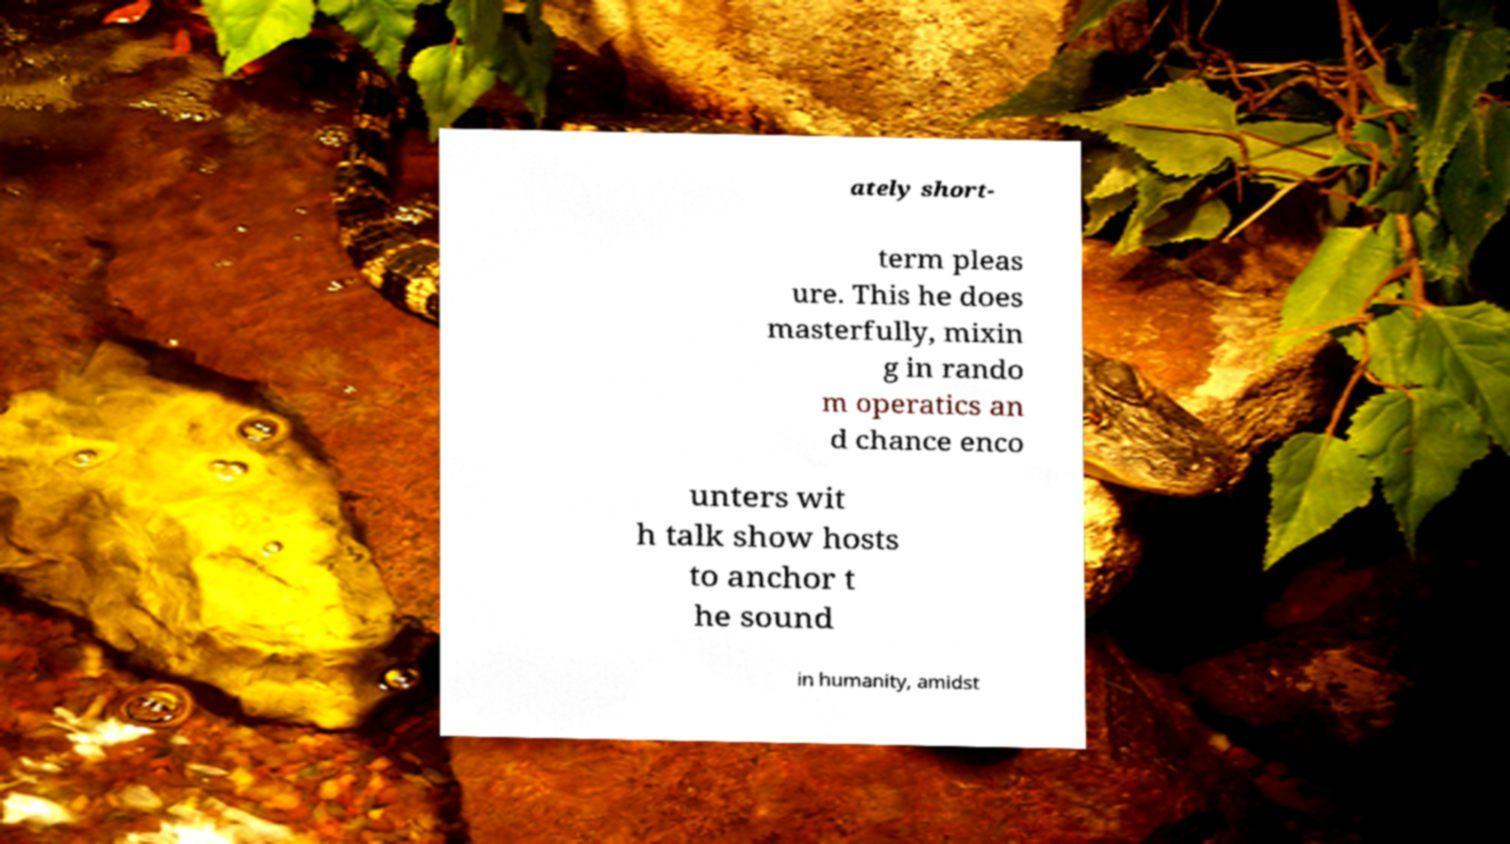Could you extract and type out the text from this image? ately short- term pleas ure. This he does masterfully, mixin g in rando m operatics an d chance enco unters wit h talk show hosts to anchor t he sound in humanity, amidst 